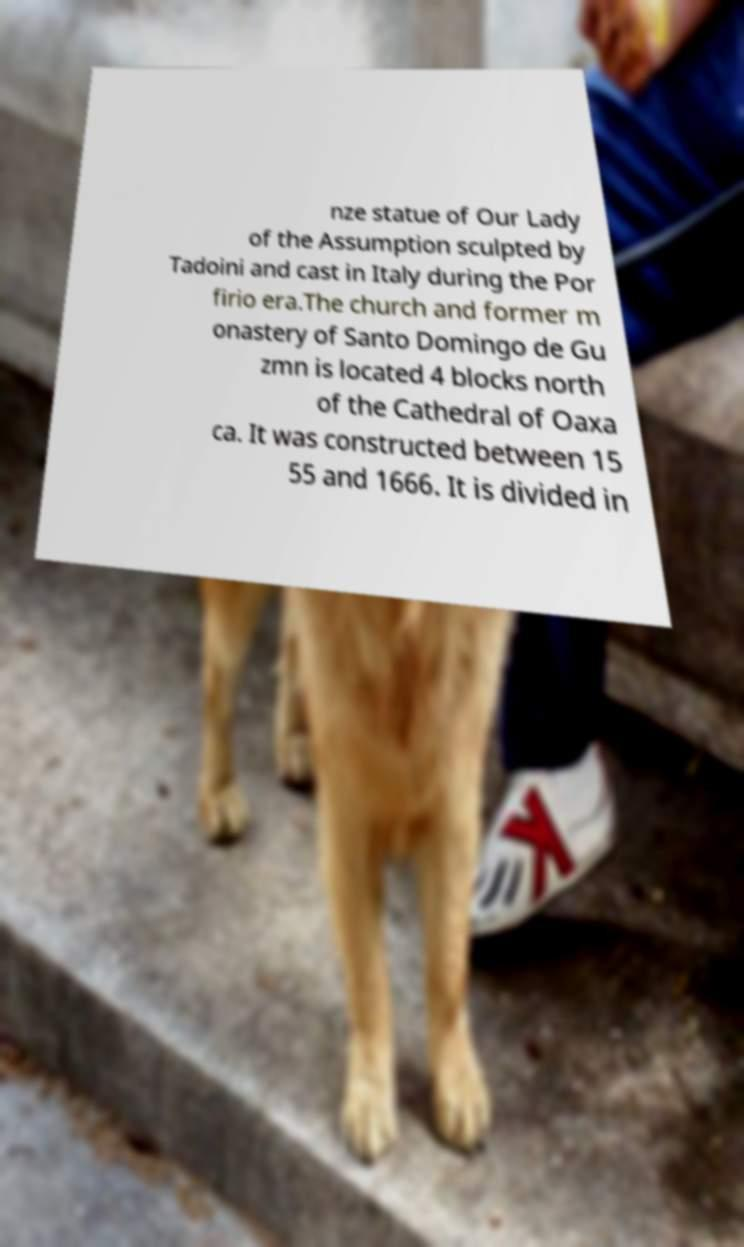There's text embedded in this image that I need extracted. Can you transcribe it verbatim? nze statue of Our Lady of the Assumption sculpted by Tadoini and cast in Italy during the Por firio era.The church and former m onastery of Santo Domingo de Gu zmn is located 4 blocks north of the Cathedral of Oaxa ca. It was constructed between 15 55 and 1666. It is divided in 